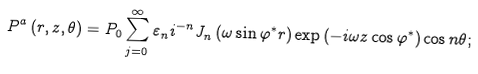<formula> <loc_0><loc_0><loc_500><loc_500>P ^ { a } \left ( r , z , \theta \right ) = P _ { 0 } \sum _ { j = 0 } ^ { \infty } \varepsilon _ { n } i ^ { - n } J _ { n } \left ( \omega \sin \varphi ^ { \ast } r \right ) \exp \left ( - i \omega z \cos \varphi ^ { \ast } \right ) \cos n \theta ;</formula> 